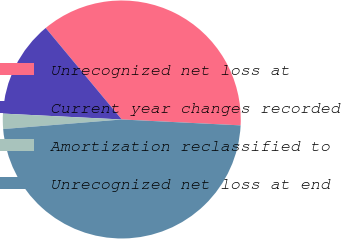Convert chart. <chart><loc_0><loc_0><loc_500><loc_500><pie_chart><fcel>Unrecognized net loss at<fcel>Current year changes recorded<fcel>Amortization reclassified to<fcel>Unrecognized net loss at end<nl><fcel>36.83%<fcel>13.17%<fcel>2.07%<fcel>47.93%<nl></chart> 